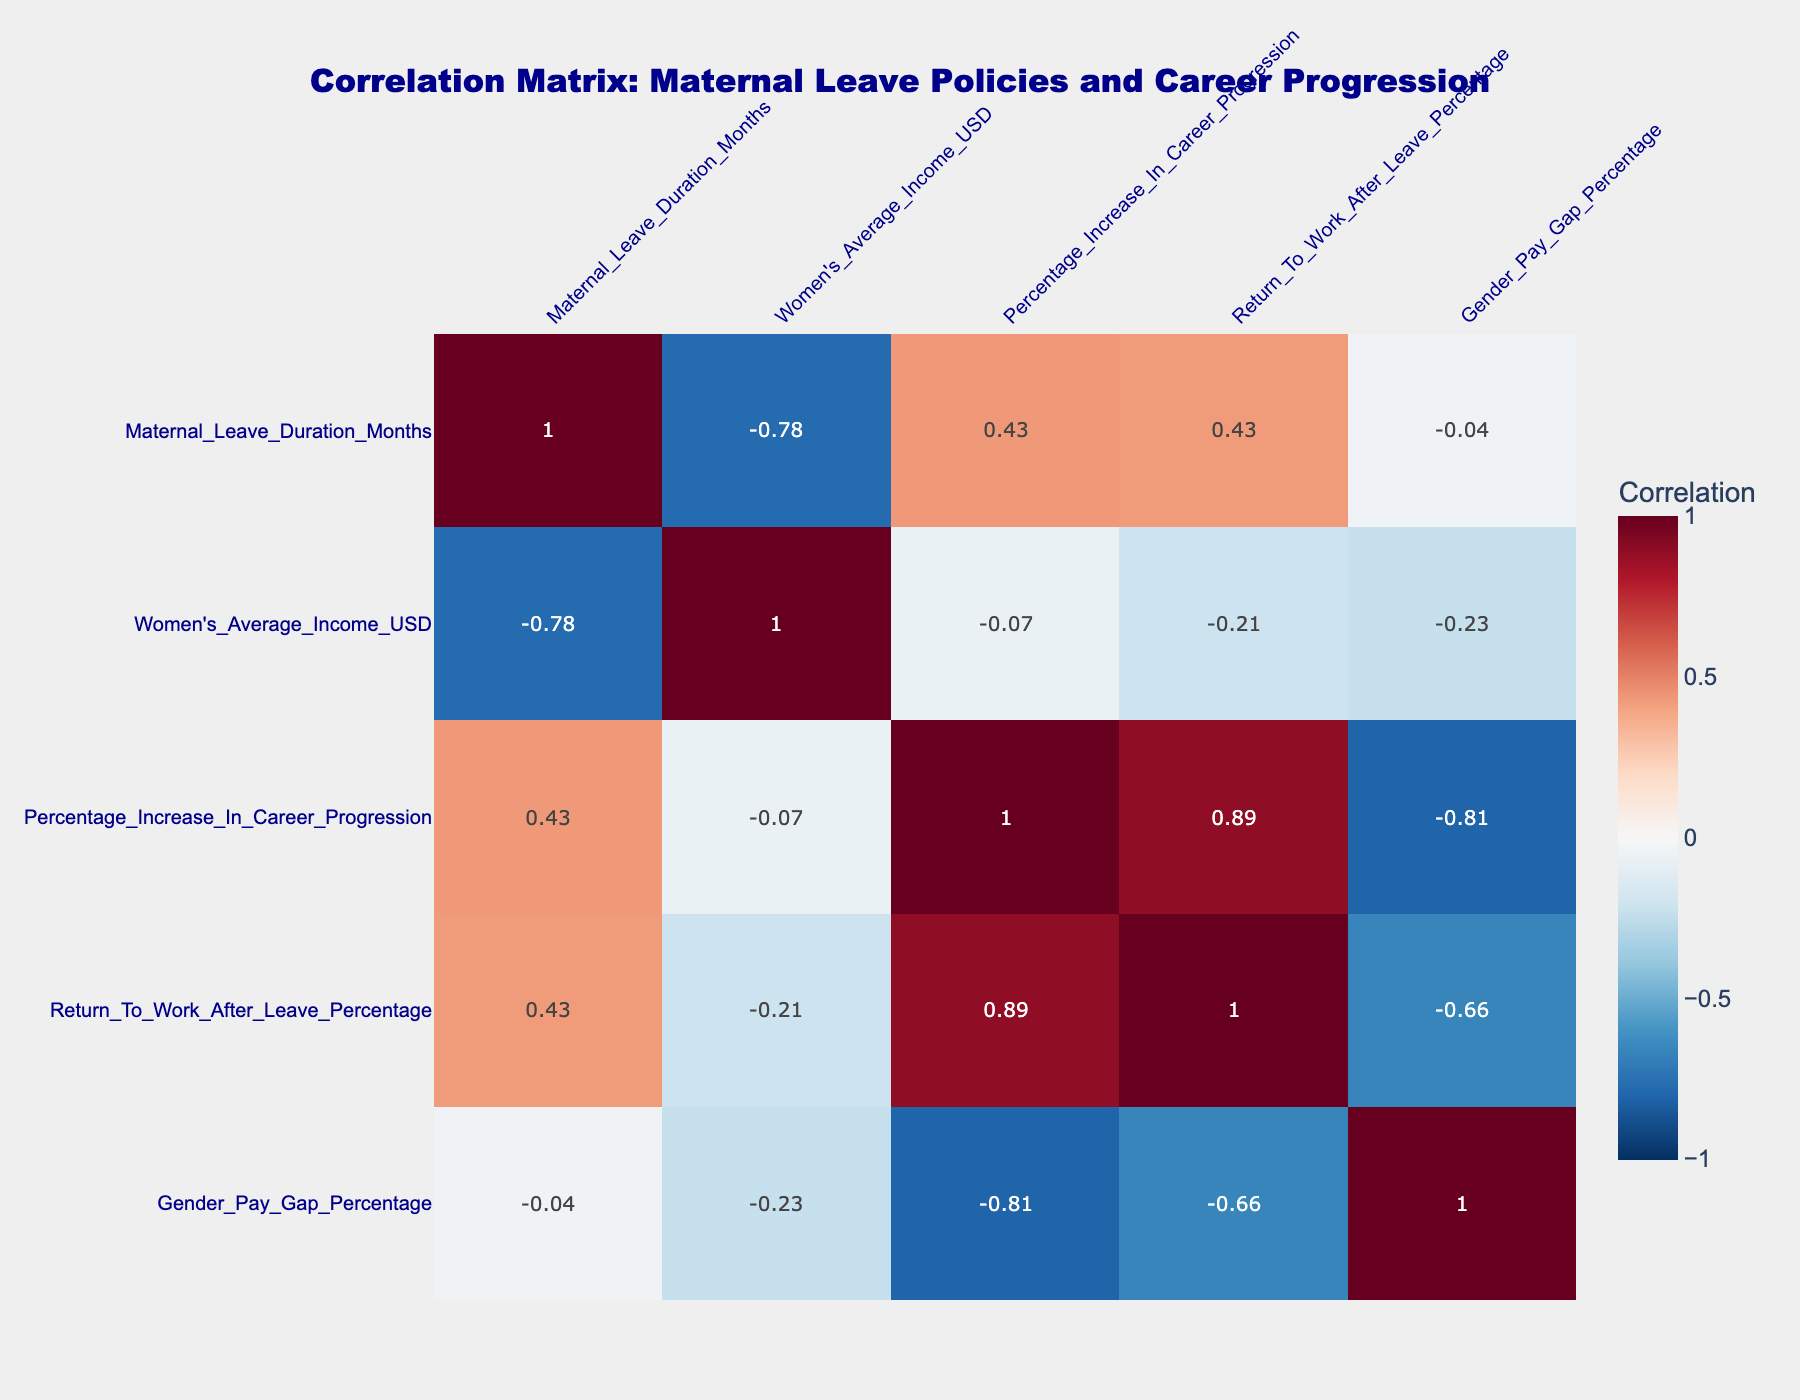What is the maternal leave duration in Germany? The table lists the maternal leave duration for each country. For Germany, it shows 14 months.
Answer: 14 months Which country has the highest women's average income? By reviewing the women's average income column, the United States has the highest value at 45000 USD.
Answer: 45000 USD What is the gender pay gap percentage in Sweden? The table indicates a gender pay gap percentage specifically for Sweden, which is shown as 12 percent.
Answer: 12 percent Is the percentage increase in career progression higher in Canada than in France? The percentage increase in career progression for Canada is 18, while for France it is 12. Since 18 is greater than 12, the statement is true.
Answer: Yes What is the average women's income of the countries with a maternal leave duration of 12 months? The countries with a 12-month maternal leave are Sweden, Norway, Canada, Australia, and South Korea. Their incomes are 36300, 38000, 37000, 36000, and 34000 respectively. Summing these gives 181300, and dividing by 5 gives an average of 36260.
Answer: 36260 USD Which country has the lowest return to work after leave percentage? In the table, Japan has the lowest return to work after leave percentage at 70 percent.
Answer: 70 percent If we consider the correlation between maternal leave duration and women's average income, would this correlation be expected to be positive? Generally, longer maternal leave is associated with lower women's average income due to lower workforce participation rates. Evaluating the correlations in the table, one should find a negative correlation, indicating that longer leaves might not translate to higher income.
Answer: No Which country has a higher percentage increase in career progression: Canada or the United Kingdom? By inspecting the respective values, Canada has an 18 percent increase in career progression, whereas the United Kingdom has 8 percent. Since 18 is greater than 8, Canada has the higher percentage.
Answer: Canada Is there any country with a maternal leave duration of 0 months? Looking through the durations provided in the table, the United States has a maternal leave duration listed as 0 months.
Answer: Yes 